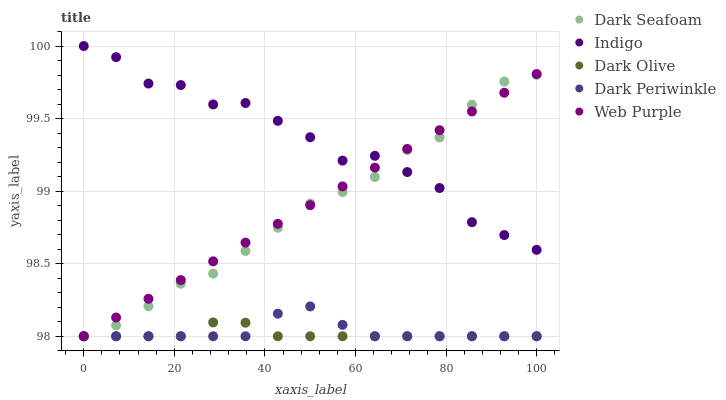Does Dark Olive have the minimum area under the curve?
Answer yes or no. Yes. Does Indigo have the maximum area under the curve?
Answer yes or no. Yes. Does Dark Seafoam have the minimum area under the curve?
Answer yes or no. No. Does Dark Seafoam have the maximum area under the curve?
Answer yes or no. No. Is Web Purple the smoothest?
Answer yes or no. Yes. Is Indigo the roughest?
Answer yes or no. Yes. Is Dark Seafoam the smoothest?
Answer yes or no. No. Is Dark Seafoam the roughest?
Answer yes or no. No. Does Web Purple have the lowest value?
Answer yes or no. Yes. Does Indigo have the lowest value?
Answer yes or no. No. Does Indigo have the highest value?
Answer yes or no. Yes. Does Dark Seafoam have the highest value?
Answer yes or no. No. Is Dark Olive less than Indigo?
Answer yes or no. Yes. Is Indigo greater than Dark Periwinkle?
Answer yes or no. Yes. Does Dark Olive intersect Dark Seafoam?
Answer yes or no. Yes. Is Dark Olive less than Dark Seafoam?
Answer yes or no. No. Is Dark Olive greater than Dark Seafoam?
Answer yes or no. No. Does Dark Olive intersect Indigo?
Answer yes or no. No. 